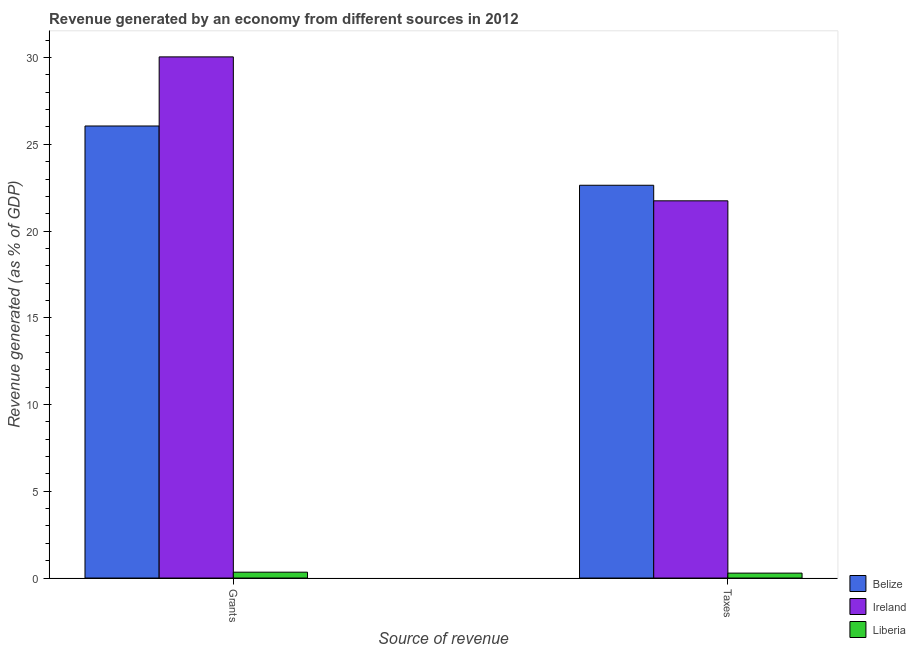What is the label of the 1st group of bars from the left?
Offer a very short reply. Grants. What is the revenue generated by grants in Ireland?
Your response must be concise. 30.04. Across all countries, what is the maximum revenue generated by grants?
Offer a very short reply. 30.04. Across all countries, what is the minimum revenue generated by taxes?
Provide a short and direct response. 0.28. In which country was the revenue generated by grants maximum?
Your answer should be very brief. Ireland. In which country was the revenue generated by grants minimum?
Ensure brevity in your answer.  Liberia. What is the total revenue generated by grants in the graph?
Provide a short and direct response. 56.44. What is the difference between the revenue generated by taxes in Ireland and that in Belize?
Ensure brevity in your answer.  -0.9. What is the difference between the revenue generated by taxes in Belize and the revenue generated by grants in Liberia?
Offer a very short reply. 22.3. What is the average revenue generated by taxes per country?
Your response must be concise. 14.89. What is the difference between the revenue generated by grants and revenue generated by taxes in Ireland?
Your answer should be very brief. 8.3. What is the ratio of the revenue generated by taxes in Liberia to that in Ireland?
Provide a short and direct response. 0.01. What does the 2nd bar from the left in Grants represents?
Your answer should be very brief. Ireland. What does the 1st bar from the right in Grants represents?
Your response must be concise. Liberia. Are all the bars in the graph horizontal?
Keep it short and to the point. No. How many countries are there in the graph?
Your response must be concise. 3. What is the difference between two consecutive major ticks on the Y-axis?
Your answer should be very brief. 5. Are the values on the major ticks of Y-axis written in scientific E-notation?
Provide a short and direct response. No. Does the graph contain grids?
Your answer should be very brief. No. Where does the legend appear in the graph?
Provide a short and direct response. Bottom right. How many legend labels are there?
Provide a succinct answer. 3. What is the title of the graph?
Offer a very short reply. Revenue generated by an economy from different sources in 2012. Does "Russian Federation" appear as one of the legend labels in the graph?
Your answer should be compact. No. What is the label or title of the X-axis?
Keep it short and to the point. Source of revenue. What is the label or title of the Y-axis?
Provide a succinct answer. Revenue generated (as % of GDP). What is the Revenue generated (as % of GDP) in Belize in Grants?
Your answer should be very brief. 26.06. What is the Revenue generated (as % of GDP) of Ireland in Grants?
Your answer should be very brief. 30.04. What is the Revenue generated (as % of GDP) in Liberia in Grants?
Give a very brief answer. 0.34. What is the Revenue generated (as % of GDP) of Belize in Taxes?
Provide a succinct answer. 22.64. What is the Revenue generated (as % of GDP) of Ireland in Taxes?
Offer a terse response. 21.74. What is the Revenue generated (as % of GDP) in Liberia in Taxes?
Offer a terse response. 0.28. Across all Source of revenue, what is the maximum Revenue generated (as % of GDP) of Belize?
Offer a terse response. 26.06. Across all Source of revenue, what is the maximum Revenue generated (as % of GDP) in Ireland?
Give a very brief answer. 30.04. Across all Source of revenue, what is the maximum Revenue generated (as % of GDP) in Liberia?
Give a very brief answer. 0.34. Across all Source of revenue, what is the minimum Revenue generated (as % of GDP) in Belize?
Offer a terse response. 22.64. Across all Source of revenue, what is the minimum Revenue generated (as % of GDP) of Ireland?
Keep it short and to the point. 21.74. Across all Source of revenue, what is the minimum Revenue generated (as % of GDP) in Liberia?
Provide a succinct answer. 0.28. What is the total Revenue generated (as % of GDP) of Belize in the graph?
Provide a succinct answer. 48.7. What is the total Revenue generated (as % of GDP) in Ireland in the graph?
Ensure brevity in your answer.  51.78. What is the total Revenue generated (as % of GDP) in Liberia in the graph?
Offer a terse response. 0.62. What is the difference between the Revenue generated (as % of GDP) in Belize in Grants and that in Taxes?
Give a very brief answer. 3.42. What is the difference between the Revenue generated (as % of GDP) in Ireland in Grants and that in Taxes?
Offer a terse response. 8.3. What is the difference between the Revenue generated (as % of GDP) of Liberia in Grants and that in Taxes?
Your response must be concise. 0.05. What is the difference between the Revenue generated (as % of GDP) of Belize in Grants and the Revenue generated (as % of GDP) of Ireland in Taxes?
Your response must be concise. 4.31. What is the difference between the Revenue generated (as % of GDP) in Belize in Grants and the Revenue generated (as % of GDP) in Liberia in Taxes?
Keep it short and to the point. 25.77. What is the difference between the Revenue generated (as % of GDP) in Ireland in Grants and the Revenue generated (as % of GDP) in Liberia in Taxes?
Make the answer very short. 29.76. What is the average Revenue generated (as % of GDP) of Belize per Source of revenue?
Provide a succinct answer. 24.35. What is the average Revenue generated (as % of GDP) of Ireland per Source of revenue?
Offer a very short reply. 25.89. What is the average Revenue generated (as % of GDP) in Liberia per Source of revenue?
Your answer should be very brief. 0.31. What is the difference between the Revenue generated (as % of GDP) in Belize and Revenue generated (as % of GDP) in Ireland in Grants?
Provide a succinct answer. -3.98. What is the difference between the Revenue generated (as % of GDP) of Belize and Revenue generated (as % of GDP) of Liberia in Grants?
Keep it short and to the point. 25.72. What is the difference between the Revenue generated (as % of GDP) in Ireland and Revenue generated (as % of GDP) in Liberia in Grants?
Your answer should be very brief. 29.7. What is the difference between the Revenue generated (as % of GDP) in Belize and Revenue generated (as % of GDP) in Ireland in Taxes?
Make the answer very short. 0.9. What is the difference between the Revenue generated (as % of GDP) in Belize and Revenue generated (as % of GDP) in Liberia in Taxes?
Give a very brief answer. 22.36. What is the difference between the Revenue generated (as % of GDP) in Ireland and Revenue generated (as % of GDP) in Liberia in Taxes?
Ensure brevity in your answer.  21.46. What is the ratio of the Revenue generated (as % of GDP) in Belize in Grants to that in Taxes?
Make the answer very short. 1.15. What is the ratio of the Revenue generated (as % of GDP) in Ireland in Grants to that in Taxes?
Offer a very short reply. 1.38. What is the ratio of the Revenue generated (as % of GDP) of Liberia in Grants to that in Taxes?
Keep it short and to the point. 1.19. What is the difference between the highest and the second highest Revenue generated (as % of GDP) of Belize?
Provide a short and direct response. 3.42. What is the difference between the highest and the second highest Revenue generated (as % of GDP) in Ireland?
Your response must be concise. 8.3. What is the difference between the highest and the second highest Revenue generated (as % of GDP) in Liberia?
Give a very brief answer. 0.05. What is the difference between the highest and the lowest Revenue generated (as % of GDP) of Belize?
Make the answer very short. 3.42. What is the difference between the highest and the lowest Revenue generated (as % of GDP) in Ireland?
Provide a short and direct response. 8.3. What is the difference between the highest and the lowest Revenue generated (as % of GDP) of Liberia?
Give a very brief answer. 0.05. 